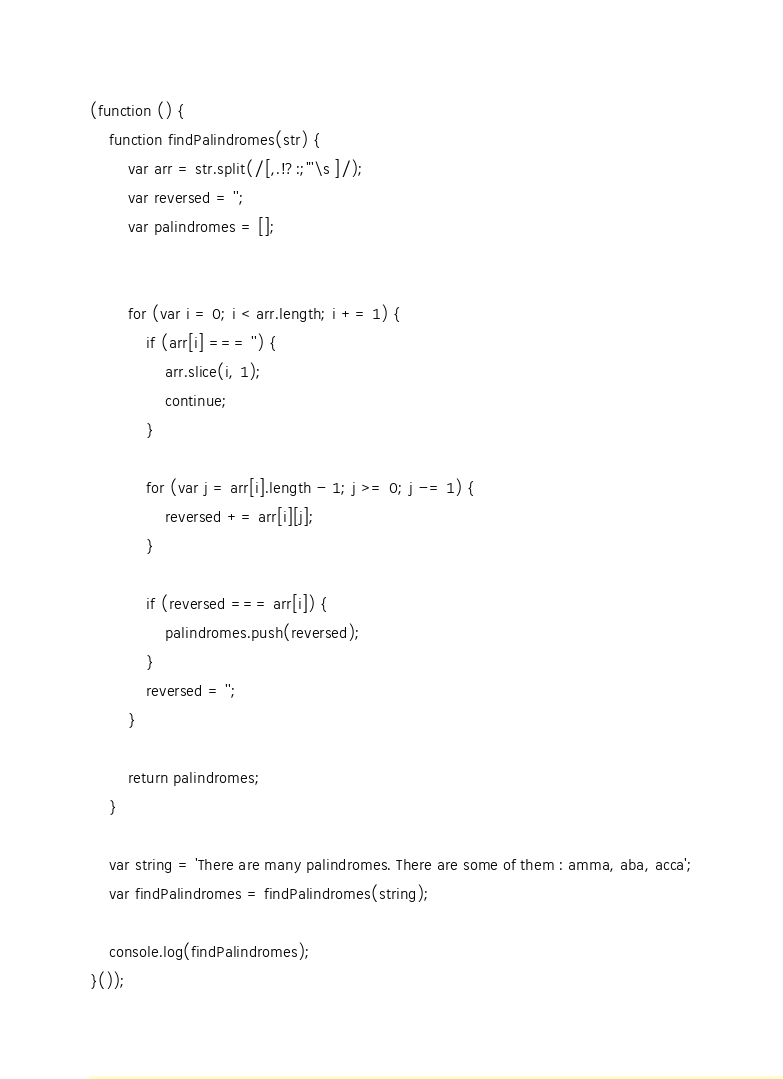Convert code to text. <code><loc_0><loc_0><loc_500><loc_500><_JavaScript_>(function () {
    function findPalindromes(str) {
        var arr = str.split(/[,.!?:;"'\s ]/);
        var reversed = '';
        var palindromes = [];


        for (var i = 0; i < arr.length; i += 1) {
            if (arr[i] === '') {
                arr.slice(i, 1);
                continue;
            }

            for (var j = arr[i].length - 1; j >= 0; j -= 1) {
                reversed += arr[i][j];
            }

            if (reversed === arr[i]) {
                palindromes.push(reversed);
            }
            reversed = '';
        }

        return palindromes;
    }

    var string = 'There are many palindromes. There are some of them : amma, aba, acca';
    var findPalindromes = findPalindromes(string);

    console.log(findPalindromes);
}());</code> 